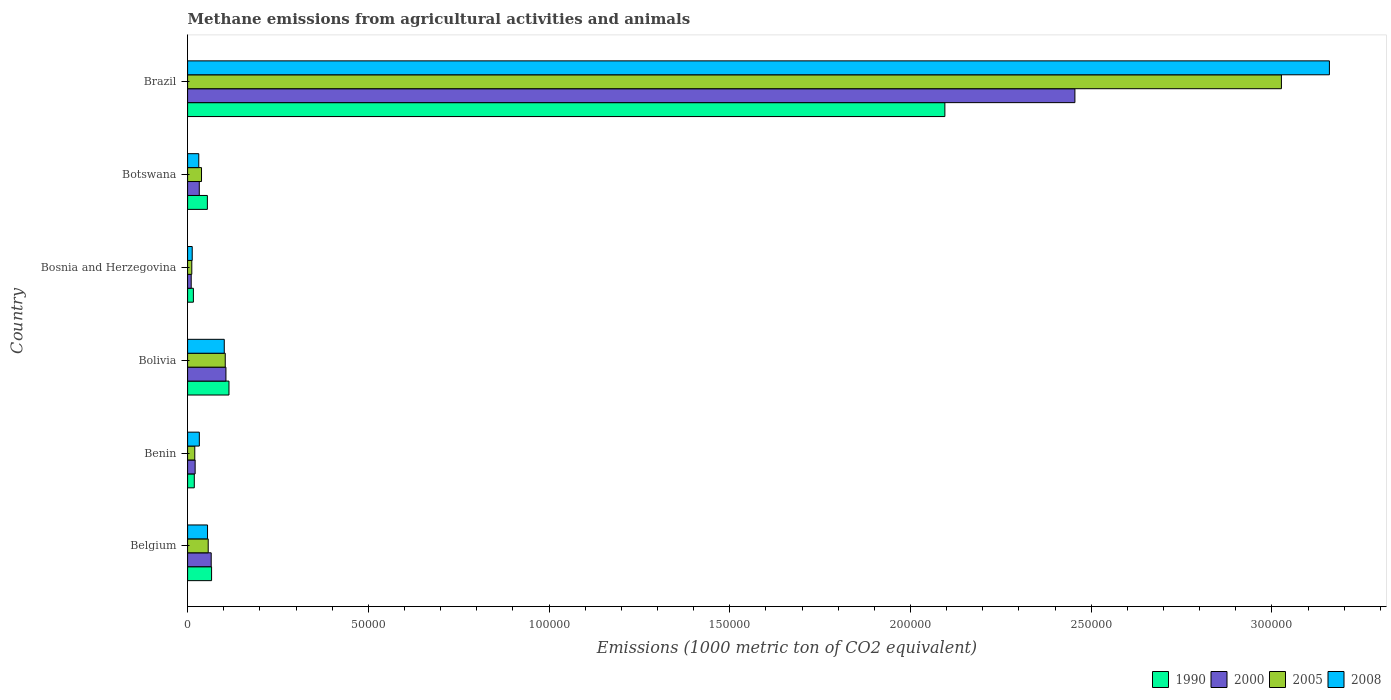How many different coloured bars are there?
Your answer should be very brief. 4. Are the number of bars on each tick of the Y-axis equal?
Keep it short and to the point. Yes. How many bars are there on the 4th tick from the bottom?
Keep it short and to the point. 4. What is the label of the 5th group of bars from the top?
Your answer should be compact. Benin. In how many cases, is the number of bars for a given country not equal to the number of legend labels?
Your answer should be compact. 0. What is the amount of methane emitted in 2008 in Bosnia and Herzegovina?
Make the answer very short. 1279.4. Across all countries, what is the maximum amount of methane emitted in 2000?
Give a very brief answer. 2.45e+05. Across all countries, what is the minimum amount of methane emitted in 1990?
Your answer should be compact. 1604.3. In which country was the amount of methane emitted in 1990 maximum?
Provide a short and direct response. Brazil. In which country was the amount of methane emitted in 2008 minimum?
Ensure brevity in your answer.  Bosnia and Herzegovina. What is the total amount of methane emitted in 2000 in the graph?
Provide a succinct answer. 2.69e+05. What is the difference between the amount of methane emitted in 1990 in Belgium and that in Bolivia?
Give a very brief answer. -4810.7. What is the difference between the amount of methane emitted in 2008 in Bolivia and the amount of methane emitted in 2005 in Benin?
Your response must be concise. 8158.3. What is the average amount of methane emitted in 2008 per country?
Provide a succinct answer. 5.65e+04. What is the difference between the amount of methane emitted in 2005 and amount of methane emitted in 2000 in Botswana?
Your response must be concise. 616.6. What is the ratio of the amount of methane emitted in 1990 in Benin to that in Bolivia?
Your answer should be very brief. 0.16. Is the difference between the amount of methane emitted in 2005 in Belgium and Brazil greater than the difference between the amount of methane emitted in 2000 in Belgium and Brazil?
Your answer should be compact. No. What is the difference between the highest and the second highest amount of methane emitted in 2008?
Make the answer very short. 3.06e+05. What is the difference between the highest and the lowest amount of methane emitted in 2000?
Make the answer very short. 2.44e+05. In how many countries, is the amount of methane emitted in 2008 greater than the average amount of methane emitted in 2008 taken over all countries?
Ensure brevity in your answer.  1. What does the 4th bar from the top in Bosnia and Herzegovina represents?
Give a very brief answer. 1990. Is it the case that in every country, the sum of the amount of methane emitted in 2000 and amount of methane emitted in 2005 is greater than the amount of methane emitted in 1990?
Your response must be concise. Yes. Are all the bars in the graph horizontal?
Provide a short and direct response. Yes. How many countries are there in the graph?
Ensure brevity in your answer.  6. What is the difference between two consecutive major ticks on the X-axis?
Ensure brevity in your answer.  5.00e+04. Are the values on the major ticks of X-axis written in scientific E-notation?
Make the answer very short. No. Does the graph contain grids?
Make the answer very short. No. How many legend labels are there?
Offer a very short reply. 4. What is the title of the graph?
Provide a succinct answer. Methane emissions from agricultural activities and animals. What is the label or title of the X-axis?
Your response must be concise. Emissions (1000 metric ton of CO2 equivalent). What is the label or title of the Y-axis?
Give a very brief answer. Country. What is the Emissions (1000 metric ton of CO2 equivalent) in 1990 in Belgium?
Provide a short and direct response. 6634.3. What is the Emissions (1000 metric ton of CO2 equivalent) in 2000 in Belgium?
Your response must be concise. 6529.5. What is the Emissions (1000 metric ton of CO2 equivalent) in 2005 in Belgium?
Your response must be concise. 5701.8. What is the Emissions (1000 metric ton of CO2 equivalent) of 2008 in Belgium?
Provide a short and direct response. 5517.1. What is the Emissions (1000 metric ton of CO2 equivalent) of 1990 in Benin?
Your answer should be very brief. 1853. What is the Emissions (1000 metric ton of CO2 equivalent) of 2000 in Benin?
Offer a very short reply. 2086.3. What is the Emissions (1000 metric ton of CO2 equivalent) of 2005 in Benin?
Offer a very short reply. 1989.2. What is the Emissions (1000 metric ton of CO2 equivalent) of 2008 in Benin?
Offer a very short reply. 3247.6. What is the Emissions (1000 metric ton of CO2 equivalent) of 1990 in Bolivia?
Ensure brevity in your answer.  1.14e+04. What is the Emissions (1000 metric ton of CO2 equivalent) in 2000 in Bolivia?
Your answer should be very brief. 1.06e+04. What is the Emissions (1000 metric ton of CO2 equivalent) in 2005 in Bolivia?
Your answer should be very brief. 1.04e+04. What is the Emissions (1000 metric ton of CO2 equivalent) in 2008 in Bolivia?
Your response must be concise. 1.01e+04. What is the Emissions (1000 metric ton of CO2 equivalent) of 1990 in Bosnia and Herzegovina?
Your answer should be compact. 1604.3. What is the Emissions (1000 metric ton of CO2 equivalent) of 2000 in Bosnia and Herzegovina?
Your response must be concise. 996.6. What is the Emissions (1000 metric ton of CO2 equivalent) in 2005 in Bosnia and Herzegovina?
Make the answer very short. 1161.2. What is the Emissions (1000 metric ton of CO2 equivalent) in 2008 in Bosnia and Herzegovina?
Make the answer very short. 1279.4. What is the Emissions (1000 metric ton of CO2 equivalent) in 1990 in Botswana?
Provide a short and direct response. 5471.2. What is the Emissions (1000 metric ton of CO2 equivalent) of 2000 in Botswana?
Offer a terse response. 3234. What is the Emissions (1000 metric ton of CO2 equivalent) of 2005 in Botswana?
Offer a terse response. 3850.6. What is the Emissions (1000 metric ton of CO2 equivalent) of 2008 in Botswana?
Give a very brief answer. 3096.4. What is the Emissions (1000 metric ton of CO2 equivalent) in 1990 in Brazil?
Your answer should be very brief. 2.10e+05. What is the Emissions (1000 metric ton of CO2 equivalent) of 2000 in Brazil?
Provide a succinct answer. 2.45e+05. What is the Emissions (1000 metric ton of CO2 equivalent) of 2005 in Brazil?
Offer a very short reply. 3.03e+05. What is the Emissions (1000 metric ton of CO2 equivalent) in 2008 in Brazil?
Your answer should be very brief. 3.16e+05. Across all countries, what is the maximum Emissions (1000 metric ton of CO2 equivalent) in 1990?
Make the answer very short. 2.10e+05. Across all countries, what is the maximum Emissions (1000 metric ton of CO2 equivalent) in 2000?
Give a very brief answer. 2.45e+05. Across all countries, what is the maximum Emissions (1000 metric ton of CO2 equivalent) in 2005?
Ensure brevity in your answer.  3.03e+05. Across all countries, what is the maximum Emissions (1000 metric ton of CO2 equivalent) of 2008?
Give a very brief answer. 3.16e+05. Across all countries, what is the minimum Emissions (1000 metric ton of CO2 equivalent) in 1990?
Your answer should be very brief. 1604.3. Across all countries, what is the minimum Emissions (1000 metric ton of CO2 equivalent) in 2000?
Offer a terse response. 996.6. Across all countries, what is the minimum Emissions (1000 metric ton of CO2 equivalent) in 2005?
Provide a short and direct response. 1161.2. Across all countries, what is the minimum Emissions (1000 metric ton of CO2 equivalent) in 2008?
Offer a very short reply. 1279.4. What is the total Emissions (1000 metric ton of CO2 equivalent) of 1990 in the graph?
Provide a succinct answer. 2.37e+05. What is the total Emissions (1000 metric ton of CO2 equivalent) in 2000 in the graph?
Provide a succinct answer. 2.69e+05. What is the total Emissions (1000 metric ton of CO2 equivalent) of 2005 in the graph?
Ensure brevity in your answer.  3.26e+05. What is the total Emissions (1000 metric ton of CO2 equivalent) in 2008 in the graph?
Make the answer very short. 3.39e+05. What is the difference between the Emissions (1000 metric ton of CO2 equivalent) of 1990 in Belgium and that in Benin?
Offer a terse response. 4781.3. What is the difference between the Emissions (1000 metric ton of CO2 equivalent) in 2000 in Belgium and that in Benin?
Your answer should be very brief. 4443.2. What is the difference between the Emissions (1000 metric ton of CO2 equivalent) of 2005 in Belgium and that in Benin?
Make the answer very short. 3712.6. What is the difference between the Emissions (1000 metric ton of CO2 equivalent) in 2008 in Belgium and that in Benin?
Your response must be concise. 2269.5. What is the difference between the Emissions (1000 metric ton of CO2 equivalent) in 1990 in Belgium and that in Bolivia?
Make the answer very short. -4810.7. What is the difference between the Emissions (1000 metric ton of CO2 equivalent) in 2000 in Belgium and that in Bolivia?
Provide a succinct answer. -4080.2. What is the difference between the Emissions (1000 metric ton of CO2 equivalent) in 2005 in Belgium and that in Bolivia?
Provide a succinct answer. -4714. What is the difference between the Emissions (1000 metric ton of CO2 equivalent) in 2008 in Belgium and that in Bolivia?
Your answer should be compact. -4630.4. What is the difference between the Emissions (1000 metric ton of CO2 equivalent) in 1990 in Belgium and that in Bosnia and Herzegovina?
Ensure brevity in your answer.  5030. What is the difference between the Emissions (1000 metric ton of CO2 equivalent) in 2000 in Belgium and that in Bosnia and Herzegovina?
Offer a terse response. 5532.9. What is the difference between the Emissions (1000 metric ton of CO2 equivalent) in 2005 in Belgium and that in Bosnia and Herzegovina?
Your answer should be very brief. 4540.6. What is the difference between the Emissions (1000 metric ton of CO2 equivalent) of 2008 in Belgium and that in Bosnia and Herzegovina?
Give a very brief answer. 4237.7. What is the difference between the Emissions (1000 metric ton of CO2 equivalent) of 1990 in Belgium and that in Botswana?
Provide a short and direct response. 1163.1. What is the difference between the Emissions (1000 metric ton of CO2 equivalent) of 2000 in Belgium and that in Botswana?
Your response must be concise. 3295.5. What is the difference between the Emissions (1000 metric ton of CO2 equivalent) of 2005 in Belgium and that in Botswana?
Keep it short and to the point. 1851.2. What is the difference between the Emissions (1000 metric ton of CO2 equivalent) in 2008 in Belgium and that in Botswana?
Your answer should be compact. 2420.7. What is the difference between the Emissions (1000 metric ton of CO2 equivalent) in 1990 in Belgium and that in Brazil?
Ensure brevity in your answer.  -2.03e+05. What is the difference between the Emissions (1000 metric ton of CO2 equivalent) in 2000 in Belgium and that in Brazil?
Make the answer very short. -2.39e+05. What is the difference between the Emissions (1000 metric ton of CO2 equivalent) of 2005 in Belgium and that in Brazil?
Make the answer very short. -2.97e+05. What is the difference between the Emissions (1000 metric ton of CO2 equivalent) of 2008 in Belgium and that in Brazil?
Provide a short and direct response. -3.10e+05. What is the difference between the Emissions (1000 metric ton of CO2 equivalent) in 1990 in Benin and that in Bolivia?
Offer a terse response. -9592. What is the difference between the Emissions (1000 metric ton of CO2 equivalent) of 2000 in Benin and that in Bolivia?
Your answer should be very brief. -8523.4. What is the difference between the Emissions (1000 metric ton of CO2 equivalent) in 2005 in Benin and that in Bolivia?
Your answer should be compact. -8426.6. What is the difference between the Emissions (1000 metric ton of CO2 equivalent) in 2008 in Benin and that in Bolivia?
Offer a very short reply. -6899.9. What is the difference between the Emissions (1000 metric ton of CO2 equivalent) in 1990 in Benin and that in Bosnia and Herzegovina?
Give a very brief answer. 248.7. What is the difference between the Emissions (1000 metric ton of CO2 equivalent) of 2000 in Benin and that in Bosnia and Herzegovina?
Ensure brevity in your answer.  1089.7. What is the difference between the Emissions (1000 metric ton of CO2 equivalent) of 2005 in Benin and that in Bosnia and Herzegovina?
Your answer should be compact. 828. What is the difference between the Emissions (1000 metric ton of CO2 equivalent) of 2008 in Benin and that in Bosnia and Herzegovina?
Give a very brief answer. 1968.2. What is the difference between the Emissions (1000 metric ton of CO2 equivalent) in 1990 in Benin and that in Botswana?
Make the answer very short. -3618.2. What is the difference between the Emissions (1000 metric ton of CO2 equivalent) in 2000 in Benin and that in Botswana?
Ensure brevity in your answer.  -1147.7. What is the difference between the Emissions (1000 metric ton of CO2 equivalent) of 2005 in Benin and that in Botswana?
Your answer should be very brief. -1861.4. What is the difference between the Emissions (1000 metric ton of CO2 equivalent) in 2008 in Benin and that in Botswana?
Provide a succinct answer. 151.2. What is the difference between the Emissions (1000 metric ton of CO2 equivalent) in 1990 in Benin and that in Brazil?
Give a very brief answer. -2.08e+05. What is the difference between the Emissions (1000 metric ton of CO2 equivalent) of 2000 in Benin and that in Brazil?
Your answer should be very brief. -2.43e+05. What is the difference between the Emissions (1000 metric ton of CO2 equivalent) in 2005 in Benin and that in Brazil?
Your answer should be very brief. -3.01e+05. What is the difference between the Emissions (1000 metric ton of CO2 equivalent) in 2008 in Benin and that in Brazil?
Keep it short and to the point. -3.13e+05. What is the difference between the Emissions (1000 metric ton of CO2 equivalent) of 1990 in Bolivia and that in Bosnia and Herzegovina?
Make the answer very short. 9840.7. What is the difference between the Emissions (1000 metric ton of CO2 equivalent) of 2000 in Bolivia and that in Bosnia and Herzegovina?
Your answer should be very brief. 9613.1. What is the difference between the Emissions (1000 metric ton of CO2 equivalent) in 2005 in Bolivia and that in Bosnia and Herzegovina?
Provide a succinct answer. 9254.6. What is the difference between the Emissions (1000 metric ton of CO2 equivalent) in 2008 in Bolivia and that in Bosnia and Herzegovina?
Provide a succinct answer. 8868.1. What is the difference between the Emissions (1000 metric ton of CO2 equivalent) in 1990 in Bolivia and that in Botswana?
Keep it short and to the point. 5973.8. What is the difference between the Emissions (1000 metric ton of CO2 equivalent) of 2000 in Bolivia and that in Botswana?
Ensure brevity in your answer.  7375.7. What is the difference between the Emissions (1000 metric ton of CO2 equivalent) in 2005 in Bolivia and that in Botswana?
Provide a short and direct response. 6565.2. What is the difference between the Emissions (1000 metric ton of CO2 equivalent) of 2008 in Bolivia and that in Botswana?
Offer a very short reply. 7051.1. What is the difference between the Emissions (1000 metric ton of CO2 equivalent) of 1990 in Bolivia and that in Brazil?
Provide a short and direct response. -1.98e+05. What is the difference between the Emissions (1000 metric ton of CO2 equivalent) in 2000 in Bolivia and that in Brazil?
Provide a succinct answer. -2.35e+05. What is the difference between the Emissions (1000 metric ton of CO2 equivalent) in 2005 in Bolivia and that in Brazil?
Provide a short and direct response. -2.92e+05. What is the difference between the Emissions (1000 metric ton of CO2 equivalent) in 2008 in Bolivia and that in Brazil?
Offer a very short reply. -3.06e+05. What is the difference between the Emissions (1000 metric ton of CO2 equivalent) in 1990 in Bosnia and Herzegovina and that in Botswana?
Give a very brief answer. -3866.9. What is the difference between the Emissions (1000 metric ton of CO2 equivalent) of 2000 in Bosnia and Herzegovina and that in Botswana?
Your response must be concise. -2237.4. What is the difference between the Emissions (1000 metric ton of CO2 equivalent) in 2005 in Bosnia and Herzegovina and that in Botswana?
Ensure brevity in your answer.  -2689.4. What is the difference between the Emissions (1000 metric ton of CO2 equivalent) of 2008 in Bosnia and Herzegovina and that in Botswana?
Keep it short and to the point. -1817. What is the difference between the Emissions (1000 metric ton of CO2 equivalent) in 1990 in Bosnia and Herzegovina and that in Brazil?
Make the answer very short. -2.08e+05. What is the difference between the Emissions (1000 metric ton of CO2 equivalent) in 2000 in Bosnia and Herzegovina and that in Brazil?
Provide a short and direct response. -2.44e+05. What is the difference between the Emissions (1000 metric ton of CO2 equivalent) in 2005 in Bosnia and Herzegovina and that in Brazil?
Provide a succinct answer. -3.01e+05. What is the difference between the Emissions (1000 metric ton of CO2 equivalent) in 2008 in Bosnia and Herzegovina and that in Brazil?
Provide a succinct answer. -3.15e+05. What is the difference between the Emissions (1000 metric ton of CO2 equivalent) of 1990 in Botswana and that in Brazil?
Give a very brief answer. -2.04e+05. What is the difference between the Emissions (1000 metric ton of CO2 equivalent) in 2000 in Botswana and that in Brazil?
Give a very brief answer. -2.42e+05. What is the difference between the Emissions (1000 metric ton of CO2 equivalent) of 2005 in Botswana and that in Brazil?
Ensure brevity in your answer.  -2.99e+05. What is the difference between the Emissions (1000 metric ton of CO2 equivalent) in 2008 in Botswana and that in Brazil?
Ensure brevity in your answer.  -3.13e+05. What is the difference between the Emissions (1000 metric ton of CO2 equivalent) in 1990 in Belgium and the Emissions (1000 metric ton of CO2 equivalent) in 2000 in Benin?
Ensure brevity in your answer.  4548. What is the difference between the Emissions (1000 metric ton of CO2 equivalent) of 1990 in Belgium and the Emissions (1000 metric ton of CO2 equivalent) of 2005 in Benin?
Provide a succinct answer. 4645.1. What is the difference between the Emissions (1000 metric ton of CO2 equivalent) in 1990 in Belgium and the Emissions (1000 metric ton of CO2 equivalent) in 2008 in Benin?
Your answer should be compact. 3386.7. What is the difference between the Emissions (1000 metric ton of CO2 equivalent) in 2000 in Belgium and the Emissions (1000 metric ton of CO2 equivalent) in 2005 in Benin?
Keep it short and to the point. 4540.3. What is the difference between the Emissions (1000 metric ton of CO2 equivalent) in 2000 in Belgium and the Emissions (1000 metric ton of CO2 equivalent) in 2008 in Benin?
Give a very brief answer. 3281.9. What is the difference between the Emissions (1000 metric ton of CO2 equivalent) in 2005 in Belgium and the Emissions (1000 metric ton of CO2 equivalent) in 2008 in Benin?
Make the answer very short. 2454.2. What is the difference between the Emissions (1000 metric ton of CO2 equivalent) in 1990 in Belgium and the Emissions (1000 metric ton of CO2 equivalent) in 2000 in Bolivia?
Make the answer very short. -3975.4. What is the difference between the Emissions (1000 metric ton of CO2 equivalent) in 1990 in Belgium and the Emissions (1000 metric ton of CO2 equivalent) in 2005 in Bolivia?
Your answer should be compact. -3781.5. What is the difference between the Emissions (1000 metric ton of CO2 equivalent) in 1990 in Belgium and the Emissions (1000 metric ton of CO2 equivalent) in 2008 in Bolivia?
Offer a very short reply. -3513.2. What is the difference between the Emissions (1000 metric ton of CO2 equivalent) in 2000 in Belgium and the Emissions (1000 metric ton of CO2 equivalent) in 2005 in Bolivia?
Your response must be concise. -3886.3. What is the difference between the Emissions (1000 metric ton of CO2 equivalent) in 2000 in Belgium and the Emissions (1000 metric ton of CO2 equivalent) in 2008 in Bolivia?
Offer a very short reply. -3618. What is the difference between the Emissions (1000 metric ton of CO2 equivalent) of 2005 in Belgium and the Emissions (1000 metric ton of CO2 equivalent) of 2008 in Bolivia?
Provide a succinct answer. -4445.7. What is the difference between the Emissions (1000 metric ton of CO2 equivalent) in 1990 in Belgium and the Emissions (1000 metric ton of CO2 equivalent) in 2000 in Bosnia and Herzegovina?
Provide a succinct answer. 5637.7. What is the difference between the Emissions (1000 metric ton of CO2 equivalent) of 1990 in Belgium and the Emissions (1000 metric ton of CO2 equivalent) of 2005 in Bosnia and Herzegovina?
Your response must be concise. 5473.1. What is the difference between the Emissions (1000 metric ton of CO2 equivalent) of 1990 in Belgium and the Emissions (1000 metric ton of CO2 equivalent) of 2008 in Bosnia and Herzegovina?
Your answer should be very brief. 5354.9. What is the difference between the Emissions (1000 metric ton of CO2 equivalent) of 2000 in Belgium and the Emissions (1000 metric ton of CO2 equivalent) of 2005 in Bosnia and Herzegovina?
Provide a short and direct response. 5368.3. What is the difference between the Emissions (1000 metric ton of CO2 equivalent) in 2000 in Belgium and the Emissions (1000 metric ton of CO2 equivalent) in 2008 in Bosnia and Herzegovina?
Your answer should be compact. 5250.1. What is the difference between the Emissions (1000 metric ton of CO2 equivalent) of 2005 in Belgium and the Emissions (1000 metric ton of CO2 equivalent) of 2008 in Bosnia and Herzegovina?
Your answer should be very brief. 4422.4. What is the difference between the Emissions (1000 metric ton of CO2 equivalent) of 1990 in Belgium and the Emissions (1000 metric ton of CO2 equivalent) of 2000 in Botswana?
Offer a terse response. 3400.3. What is the difference between the Emissions (1000 metric ton of CO2 equivalent) of 1990 in Belgium and the Emissions (1000 metric ton of CO2 equivalent) of 2005 in Botswana?
Your answer should be compact. 2783.7. What is the difference between the Emissions (1000 metric ton of CO2 equivalent) in 1990 in Belgium and the Emissions (1000 metric ton of CO2 equivalent) in 2008 in Botswana?
Ensure brevity in your answer.  3537.9. What is the difference between the Emissions (1000 metric ton of CO2 equivalent) in 2000 in Belgium and the Emissions (1000 metric ton of CO2 equivalent) in 2005 in Botswana?
Provide a succinct answer. 2678.9. What is the difference between the Emissions (1000 metric ton of CO2 equivalent) of 2000 in Belgium and the Emissions (1000 metric ton of CO2 equivalent) of 2008 in Botswana?
Provide a succinct answer. 3433.1. What is the difference between the Emissions (1000 metric ton of CO2 equivalent) in 2005 in Belgium and the Emissions (1000 metric ton of CO2 equivalent) in 2008 in Botswana?
Ensure brevity in your answer.  2605.4. What is the difference between the Emissions (1000 metric ton of CO2 equivalent) in 1990 in Belgium and the Emissions (1000 metric ton of CO2 equivalent) in 2000 in Brazil?
Offer a terse response. -2.39e+05. What is the difference between the Emissions (1000 metric ton of CO2 equivalent) of 1990 in Belgium and the Emissions (1000 metric ton of CO2 equivalent) of 2005 in Brazil?
Give a very brief answer. -2.96e+05. What is the difference between the Emissions (1000 metric ton of CO2 equivalent) of 1990 in Belgium and the Emissions (1000 metric ton of CO2 equivalent) of 2008 in Brazil?
Provide a short and direct response. -3.09e+05. What is the difference between the Emissions (1000 metric ton of CO2 equivalent) in 2000 in Belgium and the Emissions (1000 metric ton of CO2 equivalent) in 2005 in Brazil?
Your response must be concise. -2.96e+05. What is the difference between the Emissions (1000 metric ton of CO2 equivalent) in 2000 in Belgium and the Emissions (1000 metric ton of CO2 equivalent) in 2008 in Brazil?
Your answer should be compact. -3.09e+05. What is the difference between the Emissions (1000 metric ton of CO2 equivalent) of 2005 in Belgium and the Emissions (1000 metric ton of CO2 equivalent) of 2008 in Brazil?
Your response must be concise. -3.10e+05. What is the difference between the Emissions (1000 metric ton of CO2 equivalent) in 1990 in Benin and the Emissions (1000 metric ton of CO2 equivalent) in 2000 in Bolivia?
Ensure brevity in your answer.  -8756.7. What is the difference between the Emissions (1000 metric ton of CO2 equivalent) of 1990 in Benin and the Emissions (1000 metric ton of CO2 equivalent) of 2005 in Bolivia?
Offer a very short reply. -8562.8. What is the difference between the Emissions (1000 metric ton of CO2 equivalent) of 1990 in Benin and the Emissions (1000 metric ton of CO2 equivalent) of 2008 in Bolivia?
Offer a very short reply. -8294.5. What is the difference between the Emissions (1000 metric ton of CO2 equivalent) of 2000 in Benin and the Emissions (1000 metric ton of CO2 equivalent) of 2005 in Bolivia?
Make the answer very short. -8329.5. What is the difference between the Emissions (1000 metric ton of CO2 equivalent) in 2000 in Benin and the Emissions (1000 metric ton of CO2 equivalent) in 2008 in Bolivia?
Offer a terse response. -8061.2. What is the difference between the Emissions (1000 metric ton of CO2 equivalent) of 2005 in Benin and the Emissions (1000 metric ton of CO2 equivalent) of 2008 in Bolivia?
Provide a succinct answer. -8158.3. What is the difference between the Emissions (1000 metric ton of CO2 equivalent) of 1990 in Benin and the Emissions (1000 metric ton of CO2 equivalent) of 2000 in Bosnia and Herzegovina?
Ensure brevity in your answer.  856.4. What is the difference between the Emissions (1000 metric ton of CO2 equivalent) of 1990 in Benin and the Emissions (1000 metric ton of CO2 equivalent) of 2005 in Bosnia and Herzegovina?
Offer a very short reply. 691.8. What is the difference between the Emissions (1000 metric ton of CO2 equivalent) of 1990 in Benin and the Emissions (1000 metric ton of CO2 equivalent) of 2008 in Bosnia and Herzegovina?
Your answer should be compact. 573.6. What is the difference between the Emissions (1000 metric ton of CO2 equivalent) of 2000 in Benin and the Emissions (1000 metric ton of CO2 equivalent) of 2005 in Bosnia and Herzegovina?
Your answer should be very brief. 925.1. What is the difference between the Emissions (1000 metric ton of CO2 equivalent) of 2000 in Benin and the Emissions (1000 metric ton of CO2 equivalent) of 2008 in Bosnia and Herzegovina?
Offer a terse response. 806.9. What is the difference between the Emissions (1000 metric ton of CO2 equivalent) of 2005 in Benin and the Emissions (1000 metric ton of CO2 equivalent) of 2008 in Bosnia and Herzegovina?
Your answer should be very brief. 709.8. What is the difference between the Emissions (1000 metric ton of CO2 equivalent) of 1990 in Benin and the Emissions (1000 metric ton of CO2 equivalent) of 2000 in Botswana?
Make the answer very short. -1381. What is the difference between the Emissions (1000 metric ton of CO2 equivalent) of 1990 in Benin and the Emissions (1000 metric ton of CO2 equivalent) of 2005 in Botswana?
Keep it short and to the point. -1997.6. What is the difference between the Emissions (1000 metric ton of CO2 equivalent) in 1990 in Benin and the Emissions (1000 metric ton of CO2 equivalent) in 2008 in Botswana?
Provide a succinct answer. -1243.4. What is the difference between the Emissions (1000 metric ton of CO2 equivalent) of 2000 in Benin and the Emissions (1000 metric ton of CO2 equivalent) of 2005 in Botswana?
Your response must be concise. -1764.3. What is the difference between the Emissions (1000 metric ton of CO2 equivalent) of 2000 in Benin and the Emissions (1000 metric ton of CO2 equivalent) of 2008 in Botswana?
Your response must be concise. -1010.1. What is the difference between the Emissions (1000 metric ton of CO2 equivalent) of 2005 in Benin and the Emissions (1000 metric ton of CO2 equivalent) of 2008 in Botswana?
Your answer should be compact. -1107.2. What is the difference between the Emissions (1000 metric ton of CO2 equivalent) in 1990 in Benin and the Emissions (1000 metric ton of CO2 equivalent) in 2000 in Brazil?
Keep it short and to the point. -2.44e+05. What is the difference between the Emissions (1000 metric ton of CO2 equivalent) in 1990 in Benin and the Emissions (1000 metric ton of CO2 equivalent) in 2005 in Brazil?
Offer a very short reply. -3.01e+05. What is the difference between the Emissions (1000 metric ton of CO2 equivalent) of 1990 in Benin and the Emissions (1000 metric ton of CO2 equivalent) of 2008 in Brazil?
Ensure brevity in your answer.  -3.14e+05. What is the difference between the Emissions (1000 metric ton of CO2 equivalent) in 2000 in Benin and the Emissions (1000 metric ton of CO2 equivalent) in 2005 in Brazil?
Ensure brevity in your answer.  -3.01e+05. What is the difference between the Emissions (1000 metric ton of CO2 equivalent) in 2000 in Benin and the Emissions (1000 metric ton of CO2 equivalent) in 2008 in Brazil?
Give a very brief answer. -3.14e+05. What is the difference between the Emissions (1000 metric ton of CO2 equivalent) in 2005 in Benin and the Emissions (1000 metric ton of CO2 equivalent) in 2008 in Brazil?
Provide a short and direct response. -3.14e+05. What is the difference between the Emissions (1000 metric ton of CO2 equivalent) in 1990 in Bolivia and the Emissions (1000 metric ton of CO2 equivalent) in 2000 in Bosnia and Herzegovina?
Make the answer very short. 1.04e+04. What is the difference between the Emissions (1000 metric ton of CO2 equivalent) in 1990 in Bolivia and the Emissions (1000 metric ton of CO2 equivalent) in 2005 in Bosnia and Herzegovina?
Offer a terse response. 1.03e+04. What is the difference between the Emissions (1000 metric ton of CO2 equivalent) of 1990 in Bolivia and the Emissions (1000 metric ton of CO2 equivalent) of 2008 in Bosnia and Herzegovina?
Offer a very short reply. 1.02e+04. What is the difference between the Emissions (1000 metric ton of CO2 equivalent) in 2000 in Bolivia and the Emissions (1000 metric ton of CO2 equivalent) in 2005 in Bosnia and Herzegovina?
Make the answer very short. 9448.5. What is the difference between the Emissions (1000 metric ton of CO2 equivalent) in 2000 in Bolivia and the Emissions (1000 metric ton of CO2 equivalent) in 2008 in Bosnia and Herzegovina?
Keep it short and to the point. 9330.3. What is the difference between the Emissions (1000 metric ton of CO2 equivalent) of 2005 in Bolivia and the Emissions (1000 metric ton of CO2 equivalent) of 2008 in Bosnia and Herzegovina?
Provide a short and direct response. 9136.4. What is the difference between the Emissions (1000 metric ton of CO2 equivalent) of 1990 in Bolivia and the Emissions (1000 metric ton of CO2 equivalent) of 2000 in Botswana?
Your answer should be very brief. 8211. What is the difference between the Emissions (1000 metric ton of CO2 equivalent) in 1990 in Bolivia and the Emissions (1000 metric ton of CO2 equivalent) in 2005 in Botswana?
Keep it short and to the point. 7594.4. What is the difference between the Emissions (1000 metric ton of CO2 equivalent) in 1990 in Bolivia and the Emissions (1000 metric ton of CO2 equivalent) in 2008 in Botswana?
Make the answer very short. 8348.6. What is the difference between the Emissions (1000 metric ton of CO2 equivalent) of 2000 in Bolivia and the Emissions (1000 metric ton of CO2 equivalent) of 2005 in Botswana?
Make the answer very short. 6759.1. What is the difference between the Emissions (1000 metric ton of CO2 equivalent) in 2000 in Bolivia and the Emissions (1000 metric ton of CO2 equivalent) in 2008 in Botswana?
Your answer should be compact. 7513.3. What is the difference between the Emissions (1000 metric ton of CO2 equivalent) in 2005 in Bolivia and the Emissions (1000 metric ton of CO2 equivalent) in 2008 in Botswana?
Your answer should be very brief. 7319.4. What is the difference between the Emissions (1000 metric ton of CO2 equivalent) of 1990 in Bolivia and the Emissions (1000 metric ton of CO2 equivalent) of 2000 in Brazil?
Provide a succinct answer. -2.34e+05. What is the difference between the Emissions (1000 metric ton of CO2 equivalent) of 1990 in Bolivia and the Emissions (1000 metric ton of CO2 equivalent) of 2005 in Brazil?
Keep it short and to the point. -2.91e+05. What is the difference between the Emissions (1000 metric ton of CO2 equivalent) in 1990 in Bolivia and the Emissions (1000 metric ton of CO2 equivalent) in 2008 in Brazil?
Give a very brief answer. -3.04e+05. What is the difference between the Emissions (1000 metric ton of CO2 equivalent) of 2000 in Bolivia and the Emissions (1000 metric ton of CO2 equivalent) of 2005 in Brazil?
Keep it short and to the point. -2.92e+05. What is the difference between the Emissions (1000 metric ton of CO2 equivalent) of 2000 in Bolivia and the Emissions (1000 metric ton of CO2 equivalent) of 2008 in Brazil?
Your response must be concise. -3.05e+05. What is the difference between the Emissions (1000 metric ton of CO2 equivalent) in 2005 in Bolivia and the Emissions (1000 metric ton of CO2 equivalent) in 2008 in Brazil?
Offer a very short reply. -3.05e+05. What is the difference between the Emissions (1000 metric ton of CO2 equivalent) in 1990 in Bosnia and Herzegovina and the Emissions (1000 metric ton of CO2 equivalent) in 2000 in Botswana?
Give a very brief answer. -1629.7. What is the difference between the Emissions (1000 metric ton of CO2 equivalent) in 1990 in Bosnia and Herzegovina and the Emissions (1000 metric ton of CO2 equivalent) in 2005 in Botswana?
Provide a succinct answer. -2246.3. What is the difference between the Emissions (1000 metric ton of CO2 equivalent) of 1990 in Bosnia and Herzegovina and the Emissions (1000 metric ton of CO2 equivalent) of 2008 in Botswana?
Your answer should be very brief. -1492.1. What is the difference between the Emissions (1000 metric ton of CO2 equivalent) in 2000 in Bosnia and Herzegovina and the Emissions (1000 metric ton of CO2 equivalent) in 2005 in Botswana?
Offer a terse response. -2854. What is the difference between the Emissions (1000 metric ton of CO2 equivalent) in 2000 in Bosnia and Herzegovina and the Emissions (1000 metric ton of CO2 equivalent) in 2008 in Botswana?
Your answer should be very brief. -2099.8. What is the difference between the Emissions (1000 metric ton of CO2 equivalent) of 2005 in Bosnia and Herzegovina and the Emissions (1000 metric ton of CO2 equivalent) of 2008 in Botswana?
Your answer should be compact. -1935.2. What is the difference between the Emissions (1000 metric ton of CO2 equivalent) in 1990 in Bosnia and Herzegovina and the Emissions (1000 metric ton of CO2 equivalent) in 2000 in Brazil?
Your answer should be compact. -2.44e+05. What is the difference between the Emissions (1000 metric ton of CO2 equivalent) of 1990 in Bosnia and Herzegovina and the Emissions (1000 metric ton of CO2 equivalent) of 2005 in Brazil?
Give a very brief answer. -3.01e+05. What is the difference between the Emissions (1000 metric ton of CO2 equivalent) of 1990 in Bosnia and Herzegovina and the Emissions (1000 metric ton of CO2 equivalent) of 2008 in Brazil?
Give a very brief answer. -3.14e+05. What is the difference between the Emissions (1000 metric ton of CO2 equivalent) in 2000 in Bosnia and Herzegovina and the Emissions (1000 metric ton of CO2 equivalent) in 2005 in Brazil?
Provide a short and direct response. -3.02e+05. What is the difference between the Emissions (1000 metric ton of CO2 equivalent) of 2000 in Bosnia and Herzegovina and the Emissions (1000 metric ton of CO2 equivalent) of 2008 in Brazil?
Provide a short and direct response. -3.15e+05. What is the difference between the Emissions (1000 metric ton of CO2 equivalent) of 2005 in Bosnia and Herzegovina and the Emissions (1000 metric ton of CO2 equivalent) of 2008 in Brazil?
Provide a succinct answer. -3.15e+05. What is the difference between the Emissions (1000 metric ton of CO2 equivalent) in 1990 in Botswana and the Emissions (1000 metric ton of CO2 equivalent) in 2000 in Brazil?
Keep it short and to the point. -2.40e+05. What is the difference between the Emissions (1000 metric ton of CO2 equivalent) in 1990 in Botswana and the Emissions (1000 metric ton of CO2 equivalent) in 2005 in Brazil?
Make the answer very short. -2.97e+05. What is the difference between the Emissions (1000 metric ton of CO2 equivalent) in 1990 in Botswana and the Emissions (1000 metric ton of CO2 equivalent) in 2008 in Brazil?
Your answer should be very brief. -3.10e+05. What is the difference between the Emissions (1000 metric ton of CO2 equivalent) of 2000 in Botswana and the Emissions (1000 metric ton of CO2 equivalent) of 2005 in Brazil?
Keep it short and to the point. -2.99e+05. What is the difference between the Emissions (1000 metric ton of CO2 equivalent) in 2000 in Botswana and the Emissions (1000 metric ton of CO2 equivalent) in 2008 in Brazil?
Make the answer very short. -3.13e+05. What is the difference between the Emissions (1000 metric ton of CO2 equivalent) in 2005 in Botswana and the Emissions (1000 metric ton of CO2 equivalent) in 2008 in Brazil?
Your response must be concise. -3.12e+05. What is the average Emissions (1000 metric ton of CO2 equivalent) of 1990 per country?
Your answer should be compact. 3.94e+04. What is the average Emissions (1000 metric ton of CO2 equivalent) of 2000 per country?
Make the answer very short. 4.48e+04. What is the average Emissions (1000 metric ton of CO2 equivalent) in 2005 per country?
Your response must be concise. 5.43e+04. What is the average Emissions (1000 metric ton of CO2 equivalent) in 2008 per country?
Your response must be concise. 5.65e+04. What is the difference between the Emissions (1000 metric ton of CO2 equivalent) in 1990 and Emissions (1000 metric ton of CO2 equivalent) in 2000 in Belgium?
Your answer should be very brief. 104.8. What is the difference between the Emissions (1000 metric ton of CO2 equivalent) of 1990 and Emissions (1000 metric ton of CO2 equivalent) of 2005 in Belgium?
Provide a succinct answer. 932.5. What is the difference between the Emissions (1000 metric ton of CO2 equivalent) in 1990 and Emissions (1000 metric ton of CO2 equivalent) in 2008 in Belgium?
Keep it short and to the point. 1117.2. What is the difference between the Emissions (1000 metric ton of CO2 equivalent) in 2000 and Emissions (1000 metric ton of CO2 equivalent) in 2005 in Belgium?
Give a very brief answer. 827.7. What is the difference between the Emissions (1000 metric ton of CO2 equivalent) in 2000 and Emissions (1000 metric ton of CO2 equivalent) in 2008 in Belgium?
Your answer should be very brief. 1012.4. What is the difference between the Emissions (1000 metric ton of CO2 equivalent) of 2005 and Emissions (1000 metric ton of CO2 equivalent) of 2008 in Belgium?
Keep it short and to the point. 184.7. What is the difference between the Emissions (1000 metric ton of CO2 equivalent) of 1990 and Emissions (1000 metric ton of CO2 equivalent) of 2000 in Benin?
Your answer should be compact. -233.3. What is the difference between the Emissions (1000 metric ton of CO2 equivalent) in 1990 and Emissions (1000 metric ton of CO2 equivalent) in 2005 in Benin?
Provide a succinct answer. -136.2. What is the difference between the Emissions (1000 metric ton of CO2 equivalent) of 1990 and Emissions (1000 metric ton of CO2 equivalent) of 2008 in Benin?
Provide a succinct answer. -1394.6. What is the difference between the Emissions (1000 metric ton of CO2 equivalent) of 2000 and Emissions (1000 metric ton of CO2 equivalent) of 2005 in Benin?
Ensure brevity in your answer.  97.1. What is the difference between the Emissions (1000 metric ton of CO2 equivalent) of 2000 and Emissions (1000 metric ton of CO2 equivalent) of 2008 in Benin?
Offer a very short reply. -1161.3. What is the difference between the Emissions (1000 metric ton of CO2 equivalent) of 2005 and Emissions (1000 metric ton of CO2 equivalent) of 2008 in Benin?
Make the answer very short. -1258.4. What is the difference between the Emissions (1000 metric ton of CO2 equivalent) of 1990 and Emissions (1000 metric ton of CO2 equivalent) of 2000 in Bolivia?
Give a very brief answer. 835.3. What is the difference between the Emissions (1000 metric ton of CO2 equivalent) of 1990 and Emissions (1000 metric ton of CO2 equivalent) of 2005 in Bolivia?
Keep it short and to the point. 1029.2. What is the difference between the Emissions (1000 metric ton of CO2 equivalent) in 1990 and Emissions (1000 metric ton of CO2 equivalent) in 2008 in Bolivia?
Keep it short and to the point. 1297.5. What is the difference between the Emissions (1000 metric ton of CO2 equivalent) in 2000 and Emissions (1000 metric ton of CO2 equivalent) in 2005 in Bolivia?
Your answer should be very brief. 193.9. What is the difference between the Emissions (1000 metric ton of CO2 equivalent) in 2000 and Emissions (1000 metric ton of CO2 equivalent) in 2008 in Bolivia?
Provide a succinct answer. 462.2. What is the difference between the Emissions (1000 metric ton of CO2 equivalent) of 2005 and Emissions (1000 metric ton of CO2 equivalent) of 2008 in Bolivia?
Provide a short and direct response. 268.3. What is the difference between the Emissions (1000 metric ton of CO2 equivalent) in 1990 and Emissions (1000 metric ton of CO2 equivalent) in 2000 in Bosnia and Herzegovina?
Ensure brevity in your answer.  607.7. What is the difference between the Emissions (1000 metric ton of CO2 equivalent) in 1990 and Emissions (1000 metric ton of CO2 equivalent) in 2005 in Bosnia and Herzegovina?
Provide a succinct answer. 443.1. What is the difference between the Emissions (1000 metric ton of CO2 equivalent) in 1990 and Emissions (1000 metric ton of CO2 equivalent) in 2008 in Bosnia and Herzegovina?
Provide a succinct answer. 324.9. What is the difference between the Emissions (1000 metric ton of CO2 equivalent) of 2000 and Emissions (1000 metric ton of CO2 equivalent) of 2005 in Bosnia and Herzegovina?
Provide a short and direct response. -164.6. What is the difference between the Emissions (1000 metric ton of CO2 equivalent) in 2000 and Emissions (1000 metric ton of CO2 equivalent) in 2008 in Bosnia and Herzegovina?
Give a very brief answer. -282.8. What is the difference between the Emissions (1000 metric ton of CO2 equivalent) in 2005 and Emissions (1000 metric ton of CO2 equivalent) in 2008 in Bosnia and Herzegovina?
Make the answer very short. -118.2. What is the difference between the Emissions (1000 metric ton of CO2 equivalent) of 1990 and Emissions (1000 metric ton of CO2 equivalent) of 2000 in Botswana?
Provide a short and direct response. 2237.2. What is the difference between the Emissions (1000 metric ton of CO2 equivalent) in 1990 and Emissions (1000 metric ton of CO2 equivalent) in 2005 in Botswana?
Make the answer very short. 1620.6. What is the difference between the Emissions (1000 metric ton of CO2 equivalent) in 1990 and Emissions (1000 metric ton of CO2 equivalent) in 2008 in Botswana?
Your response must be concise. 2374.8. What is the difference between the Emissions (1000 metric ton of CO2 equivalent) of 2000 and Emissions (1000 metric ton of CO2 equivalent) of 2005 in Botswana?
Provide a succinct answer. -616.6. What is the difference between the Emissions (1000 metric ton of CO2 equivalent) of 2000 and Emissions (1000 metric ton of CO2 equivalent) of 2008 in Botswana?
Keep it short and to the point. 137.6. What is the difference between the Emissions (1000 metric ton of CO2 equivalent) in 2005 and Emissions (1000 metric ton of CO2 equivalent) in 2008 in Botswana?
Your response must be concise. 754.2. What is the difference between the Emissions (1000 metric ton of CO2 equivalent) of 1990 and Emissions (1000 metric ton of CO2 equivalent) of 2000 in Brazil?
Provide a short and direct response. -3.60e+04. What is the difference between the Emissions (1000 metric ton of CO2 equivalent) of 1990 and Emissions (1000 metric ton of CO2 equivalent) of 2005 in Brazil?
Your answer should be compact. -9.31e+04. What is the difference between the Emissions (1000 metric ton of CO2 equivalent) in 1990 and Emissions (1000 metric ton of CO2 equivalent) in 2008 in Brazil?
Your response must be concise. -1.06e+05. What is the difference between the Emissions (1000 metric ton of CO2 equivalent) in 2000 and Emissions (1000 metric ton of CO2 equivalent) in 2005 in Brazil?
Give a very brief answer. -5.71e+04. What is the difference between the Emissions (1000 metric ton of CO2 equivalent) in 2000 and Emissions (1000 metric ton of CO2 equivalent) in 2008 in Brazil?
Your answer should be very brief. -7.04e+04. What is the difference between the Emissions (1000 metric ton of CO2 equivalent) of 2005 and Emissions (1000 metric ton of CO2 equivalent) of 2008 in Brazil?
Give a very brief answer. -1.33e+04. What is the ratio of the Emissions (1000 metric ton of CO2 equivalent) of 1990 in Belgium to that in Benin?
Your answer should be compact. 3.58. What is the ratio of the Emissions (1000 metric ton of CO2 equivalent) of 2000 in Belgium to that in Benin?
Offer a terse response. 3.13. What is the ratio of the Emissions (1000 metric ton of CO2 equivalent) of 2005 in Belgium to that in Benin?
Offer a very short reply. 2.87. What is the ratio of the Emissions (1000 metric ton of CO2 equivalent) of 2008 in Belgium to that in Benin?
Keep it short and to the point. 1.7. What is the ratio of the Emissions (1000 metric ton of CO2 equivalent) of 1990 in Belgium to that in Bolivia?
Provide a short and direct response. 0.58. What is the ratio of the Emissions (1000 metric ton of CO2 equivalent) in 2000 in Belgium to that in Bolivia?
Ensure brevity in your answer.  0.62. What is the ratio of the Emissions (1000 metric ton of CO2 equivalent) of 2005 in Belgium to that in Bolivia?
Offer a very short reply. 0.55. What is the ratio of the Emissions (1000 metric ton of CO2 equivalent) in 2008 in Belgium to that in Bolivia?
Give a very brief answer. 0.54. What is the ratio of the Emissions (1000 metric ton of CO2 equivalent) of 1990 in Belgium to that in Bosnia and Herzegovina?
Provide a short and direct response. 4.14. What is the ratio of the Emissions (1000 metric ton of CO2 equivalent) of 2000 in Belgium to that in Bosnia and Herzegovina?
Ensure brevity in your answer.  6.55. What is the ratio of the Emissions (1000 metric ton of CO2 equivalent) of 2005 in Belgium to that in Bosnia and Herzegovina?
Provide a short and direct response. 4.91. What is the ratio of the Emissions (1000 metric ton of CO2 equivalent) of 2008 in Belgium to that in Bosnia and Herzegovina?
Your answer should be very brief. 4.31. What is the ratio of the Emissions (1000 metric ton of CO2 equivalent) of 1990 in Belgium to that in Botswana?
Your response must be concise. 1.21. What is the ratio of the Emissions (1000 metric ton of CO2 equivalent) of 2000 in Belgium to that in Botswana?
Your answer should be compact. 2.02. What is the ratio of the Emissions (1000 metric ton of CO2 equivalent) in 2005 in Belgium to that in Botswana?
Your answer should be compact. 1.48. What is the ratio of the Emissions (1000 metric ton of CO2 equivalent) of 2008 in Belgium to that in Botswana?
Keep it short and to the point. 1.78. What is the ratio of the Emissions (1000 metric ton of CO2 equivalent) in 1990 in Belgium to that in Brazil?
Your answer should be very brief. 0.03. What is the ratio of the Emissions (1000 metric ton of CO2 equivalent) of 2000 in Belgium to that in Brazil?
Give a very brief answer. 0.03. What is the ratio of the Emissions (1000 metric ton of CO2 equivalent) of 2005 in Belgium to that in Brazil?
Keep it short and to the point. 0.02. What is the ratio of the Emissions (1000 metric ton of CO2 equivalent) in 2008 in Belgium to that in Brazil?
Keep it short and to the point. 0.02. What is the ratio of the Emissions (1000 metric ton of CO2 equivalent) of 1990 in Benin to that in Bolivia?
Your answer should be very brief. 0.16. What is the ratio of the Emissions (1000 metric ton of CO2 equivalent) of 2000 in Benin to that in Bolivia?
Give a very brief answer. 0.2. What is the ratio of the Emissions (1000 metric ton of CO2 equivalent) of 2005 in Benin to that in Bolivia?
Your answer should be compact. 0.19. What is the ratio of the Emissions (1000 metric ton of CO2 equivalent) of 2008 in Benin to that in Bolivia?
Give a very brief answer. 0.32. What is the ratio of the Emissions (1000 metric ton of CO2 equivalent) of 1990 in Benin to that in Bosnia and Herzegovina?
Provide a succinct answer. 1.16. What is the ratio of the Emissions (1000 metric ton of CO2 equivalent) in 2000 in Benin to that in Bosnia and Herzegovina?
Your response must be concise. 2.09. What is the ratio of the Emissions (1000 metric ton of CO2 equivalent) in 2005 in Benin to that in Bosnia and Herzegovina?
Provide a short and direct response. 1.71. What is the ratio of the Emissions (1000 metric ton of CO2 equivalent) of 2008 in Benin to that in Bosnia and Herzegovina?
Your answer should be very brief. 2.54. What is the ratio of the Emissions (1000 metric ton of CO2 equivalent) in 1990 in Benin to that in Botswana?
Offer a terse response. 0.34. What is the ratio of the Emissions (1000 metric ton of CO2 equivalent) of 2000 in Benin to that in Botswana?
Your answer should be very brief. 0.65. What is the ratio of the Emissions (1000 metric ton of CO2 equivalent) of 2005 in Benin to that in Botswana?
Make the answer very short. 0.52. What is the ratio of the Emissions (1000 metric ton of CO2 equivalent) of 2008 in Benin to that in Botswana?
Offer a terse response. 1.05. What is the ratio of the Emissions (1000 metric ton of CO2 equivalent) of 1990 in Benin to that in Brazil?
Provide a succinct answer. 0.01. What is the ratio of the Emissions (1000 metric ton of CO2 equivalent) of 2000 in Benin to that in Brazil?
Offer a very short reply. 0.01. What is the ratio of the Emissions (1000 metric ton of CO2 equivalent) in 2005 in Benin to that in Brazil?
Your answer should be compact. 0.01. What is the ratio of the Emissions (1000 metric ton of CO2 equivalent) of 2008 in Benin to that in Brazil?
Your answer should be compact. 0.01. What is the ratio of the Emissions (1000 metric ton of CO2 equivalent) of 1990 in Bolivia to that in Bosnia and Herzegovina?
Offer a very short reply. 7.13. What is the ratio of the Emissions (1000 metric ton of CO2 equivalent) in 2000 in Bolivia to that in Bosnia and Herzegovina?
Keep it short and to the point. 10.65. What is the ratio of the Emissions (1000 metric ton of CO2 equivalent) in 2005 in Bolivia to that in Bosnia and Herzegovina?
Provide a succinct answer. 8.97. What is the ratio of the Emissions (1000 metric ton of CO2 equivalent) in 2008 in Bolivia to that in Bosnia and Herzegovina?
Provide a short and direct response. 7.93. What is the ratio of the Emissions (1000 metric ton of CO2 equivalent) of 1990 in Bolivia to that in Botswana?
Your answer should be very brief. 2.09. What is the ratio of the Emissions (1000 metric ton of CO2 equivalent) in 2000 in Bolivia to that in Botswana?
Your answer should be compact. 3.28. What is the ratio of the Emissions (1000 metric ton of CO2 equivalent) of 2005 in Bolivia to that in Botswana?
Keep it short and to the point. 2.71. What is the ratio of the Emissions (1000 metric ton of CO2 equivalent) of 2008 in Bolivia to that in Botswana?
Offer a terse response. 3.28. What is the ratio of the Emissions (1000 metric ton of CO2 equivalent) in 1990 in Bolivia to that in Brazil?
Your answer should be compact. 0.05. What is the ratio of the Emissions (1000 metric ton of CO2 equivalent) in 2000 in Bolivia to that in Brazil?
Your answer should be very brief. 0.04. What is the ratio of the Emissions (1000 metric ton of CO2 equivalent) in 2005 in Bolivia to that in Brazil?
Make the answer very short. 0.03. What is the ratio of the Emissions (1000 metric ton of CO2 equivalent) of 2008 in Bolivia to that in Brazil?
Make the answer very short. 0.03. What is the ratio of the Emissions (1000 metric ton of CO2 equivalent) in 1990 in Bosnia and Herzegovina to that in Botswana?
Keep it short and to the point. 0.29. What is the ratio of the Emissions (1000 metric ton of CO2 equivalent) in 2000 in Bosnia and Herzegovina to that in Botswana?
Give a very brief answer. 0.31. What is the ratio of the Emissions (1000 metric ton of CO2 equivalent) in 2005 in Bosnia and Herzegovina to that in Botswana?
Make the answer very short. 0.3. What is the ratio of the Emissions (1000 metric ton of CO2 equivalent) of 2008 in Bosnia and Herzegovina to that in Botswana?
Give a very brief answer. 0.41. What is the ratio of the Emissions (1000 metric ton of CO2 equivalent) of 1990 in Bosnia and Herzegovina to that in Brazil?
Give a very brief answer. 0.01. What is the ratio of the Emissions (1000 metric ton of CO2 equivalent) of 2000 in Bosnia and Herzegovina to that in Brazil?
Offer a terse response. 0. What is the ratio of the Emissions (1000 metric ton of CO2 equivalent) in 2005 in Bosnia and Herzegovina to that in Brazil?
Your answer should be very brief. 0. What is the ratio of the Emissions (1000 metric ton of CO2 equivalent) in 2008 in Bosnia and Herzegovina to that in Brazil?
Give a very brief answer. 0. What is the ratio of the Emissions (1000 metric ton of CO2 equivalent) in 1990 in Botswana to that in Brazil?
Provide a succinct answer. 0.03. What is the ratio of the Emissions (1000 metric ton of CO2 equivalent) in 2000 in Botswana to that in Brazil?
Your answer should be compact. 0.01. What is the ratio of the Emissions (1000 metric ton of CO2 equivalent) in 2005 in Botswana to that in Brazil?
Offer a terse response. 0.01. What is the ratio of the Emissions (1000 metric ton of CO2 equivalent) in 2008 in Botswana to that in Brazil?
Ensure brevity in your answer.  0.01. What is the difference between the highest and the second highest Emissions (1000 metric ton of CO2 equivalent) of 1990?
Provide a succinct answer. 1.98e+05. What is the difference between the highest and the second highest Emissions (1000 metric ton of CO2 equivalent) in 2000?
Your answer should be very brief. 2.35e+05. What is the difference between the highest and the second highest Emissions (1000 metric ton of CO2 equivalent) in 2005?
Provide a succinct answer. 2.92e+05. What is the difference between the highest and the second highest Emissions (1000 metric ton of CO2 equivalent) of 2008?
Provide a short and direct response. 3.06e+05. What is the difference between the highest and the lowest Emissions (1000 metric ton of CO2 equivalent) of 1990?
Your answer should be compact. 2.08e+05. What is the difference between the highest and the lowest Emissions (1000 metric ton of CO2 equivalent) of 2000?
Your answer should be very brief. 2.44e+05. What is the difference between the highest and the lowest Emissions (1000 metric ton of CO2 equivalent) of 2005?
Your answer should be compact. 3.01e+05. What is the difference between the highest and the lowest Emissions (1000 metric ton of CO2 equivalent) in 2008?
Provide a short and direct response. 3.15e+05. 